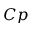<formula> <loc_0><loc_0><loc_500><loc_500>C p</formula> 